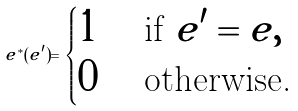Convert formula to latex. <formula><loc_0><loc_0><loc_500><loc_500>e ^ { * } ( e ^ { \prime } ) = \begin{cases} 1 & \text { if } e ^ { \prime } = e , \\ 0 & \text { otherwise.} \end{cases}</formula> 